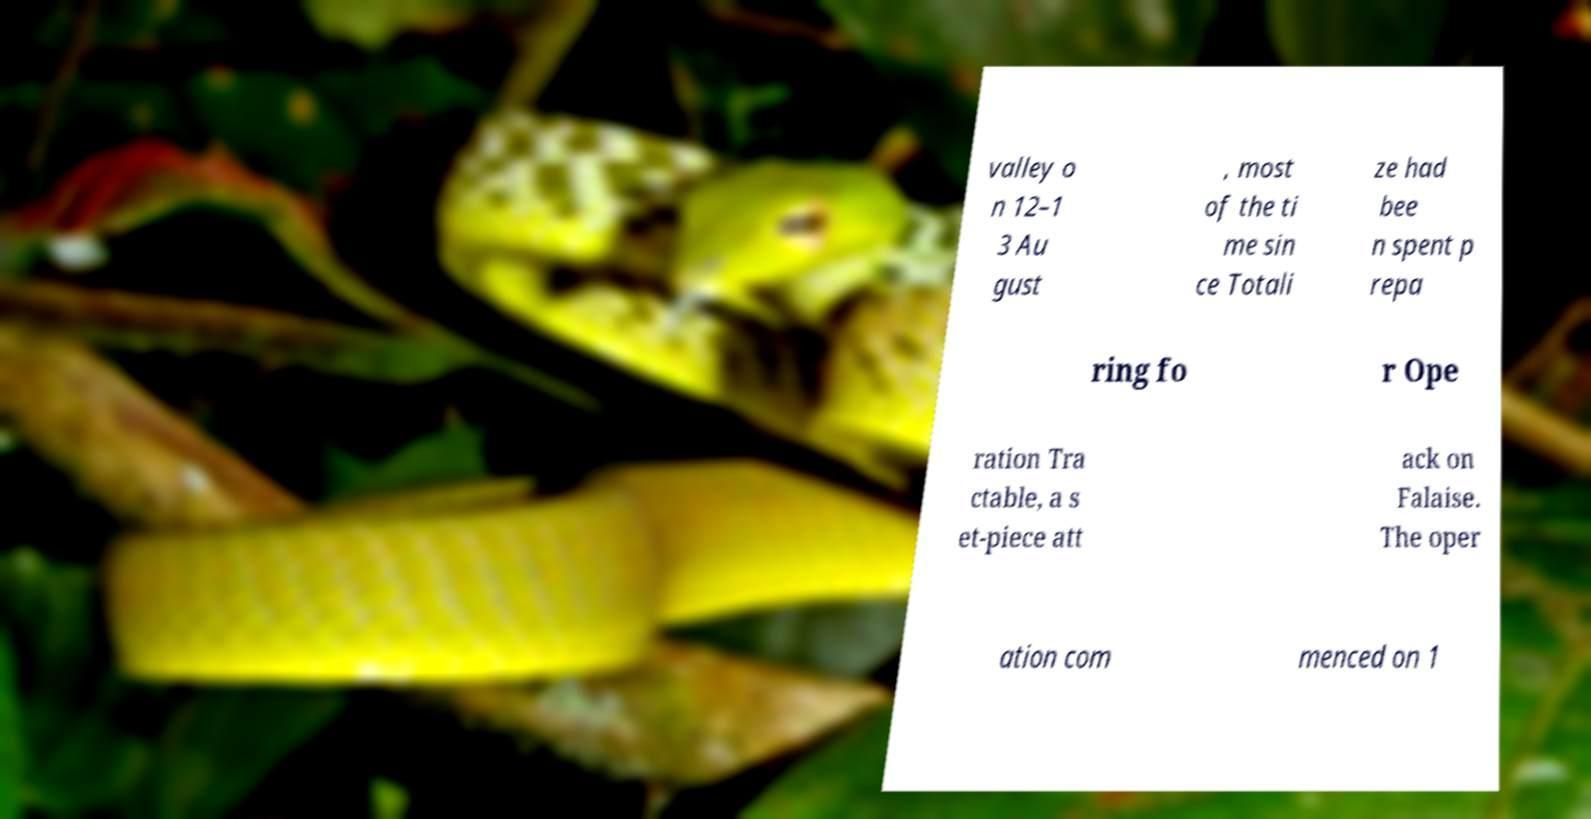There's text embedded in this image that I need extracted. Can you transcribe it verbatim? valley o n 12–1 3 Au gust , most of the ti me sin ce Totali ze had bee n spent p repa ring fo r Ope ration Tra ctable, a s et-piece att ack on Falaise. The oper ation com menced on 1 